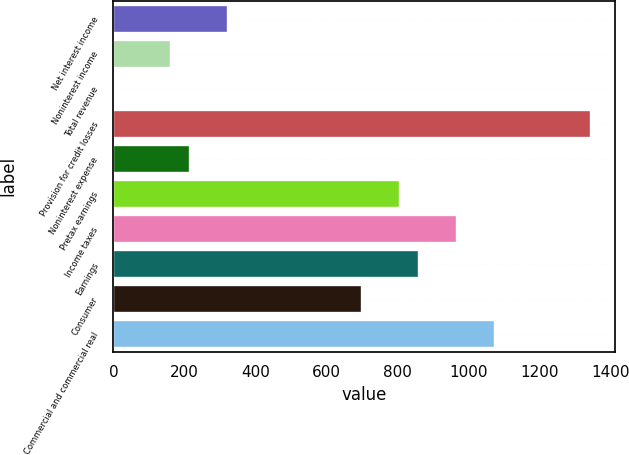Convert chart to OTSL. <chart><loc_0><loc_0><loc_500><loc_500><bar_chart><fcel>Net interest income<fcel>Noninterest income<fcel>Total revenue<fcel>Provision for credit losses<fcel>Noninterest expense<fcel>Pretax earnings<fcel>Income taxes<fcel>Earnings<fcel>Consumer<fcel>Commercial and commercial real<nl><fcel>323.2<fcel>162.1<fcel>1<fcel>1343.5<fcel>215.8<fcel>806.5<fcel>967.6<fcel>860.2<fcel>699.1<fcel>1075<nl></chart> 